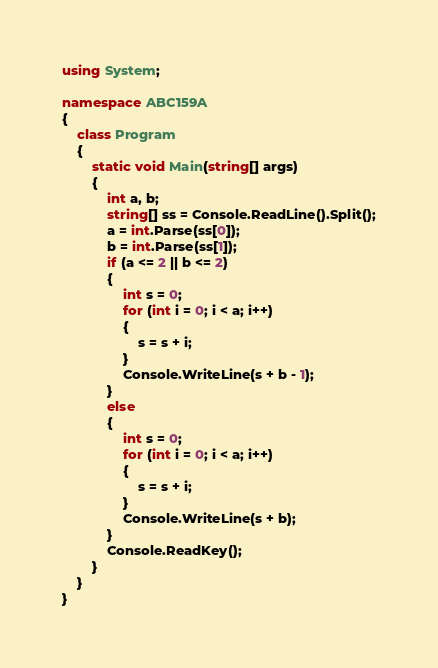<code> <loc_0><loc_0><loc_500><loc_500><_C#_>using System;

namespace ABC159A
{
    class Program
    {
        static void Main(string[] args)
        {
            int a, b;
            string[] ss = Console.ReadLine().Split();
            a = int.Parse(ss[0]);
            b = int.Parse(ss[1]);
            if (a <= 2 || b <= 2)
            {
                int s = 0;
                for (int i = 0; i < a; i++)
                {
                    s = s + i;
                }
                Console.WriteLine(s + b - 1);
            }
            else
            {
                int s = 0;
                for (int i = 0; i < a; i++)
                {
                    s = s + i;
                }
                Console.WriteLine(s + b);
            }
            Console.ReadKey();
        }
    }
}
</code> 